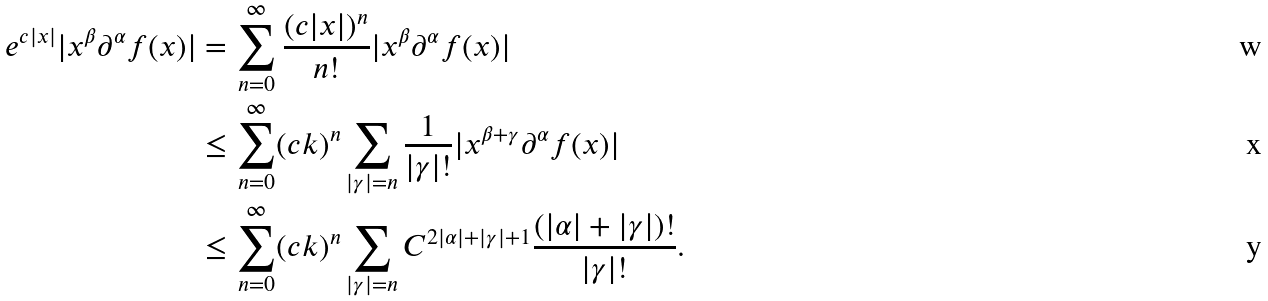<formula> <loc_0><loc_0><loc_500><loc_500>e ^ { c | x | } | x ^ { \beta } \partial ^ { \alpha } f ( x ) | & = \sum _ { n = 0 } ^ { \infty } \frac { ( c | x | ) ^ { n } } { n ! } | x ^ { \beta } \partial ^ { \alpha } f ( x ) | \\ & \leq \sum _ { n = 0 } ^ { \infty } ( c k ) ^ { n } \sum _ { | \gamma | = n } \frac { 1 } { | \gamma | ! } | x ^ { \beta + \gamma } \partial ^ { \alpha } f ( x ) | \\ & \leq \sum _ { n = 0 } ^ { \infty } ( c k ) ^ { n } \sum _ { | \gamma | = n } C ^ { 2 | \alpha | + | \gamma | + 1 } \frac { ( | \alpha | + | \gamma | ) ! } { | \gamma | ! } .</formula> 